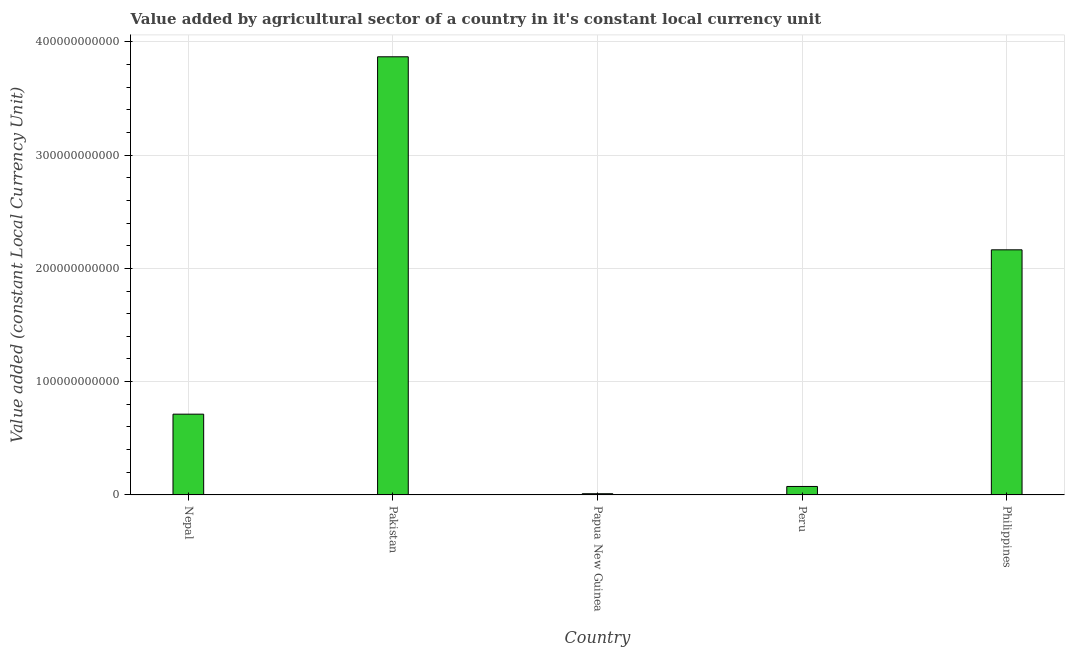Does the graph contain any zero values?
Give a very brief answer. No. What is the title of the graph?
Your response must be concise. Value added by agricultural sector of a country in it's constant local currency unit. What is the label or title of the Y-axis?
Offer a very short reply. Value added (constant Local Currency Unit). What is the value added by agriculture sector in Pakistan?
Provide a succinct answer. 3.87e+11. Across all countries, what is the maximum value added by agriculture sector?
Your answer should be compact. 3.87e+11. Across all countries, what is the minimum value added by agriculture sector?
Your answer should be compact. 1.06e+09. In which country was the value added by agriculture sector minimum?
Provide a succinct answer. Papua New Guinea. What is the sum of the value added by agriculture sector?
Give a very brief answer. 6.83e+11. What is the difference between the value added by agriculture sector in Nepal and Pakistan?
Your answer should be compact. -3.15e+11. What is the average value added by agriculture sector per country?
Offer a very short reply. 1.37e+11. What is the median value added by agriculture sector?
Ensure brevity in your answer.  7.13e+1. What is the ratio of the value added by agriculture sector in Nepal to that in Pakistan?
Your response must be concise. 0.18. Is the value added by agriculture sector in Peru less than that in Philippines?
Make the answer very short. Yes. Is the difference between the value added by agriculture sector in Peru and Philippines greater than the difference between any two countries?
Provide a succinct answer. No. What is the difference between the highest and the second highest value added by agriculture sector?
Make the answer very short. 1.70e+11. Is the sum of the value added by agriculture sector in Nepal and Pakistan greater than the maximum value added by agriculture sector across all countries?
Your answer should be very brief. Yes. What is the difference between the highest and the lowest value added by agriculture sector?
Your response must be concise. 3.86e+11. How many bars are there?
Give a very brief answer. 5. Are all the bars in the graph horizontal?
Provide a short and direct response. No. How many countries are there in the graph?
Provide a succinct answer. 5. What is the difference between two consecutive major ticks on the Y-axis?
Your answer should be very brief. 1.00e+11. What is the Value added (constant Local Currency Unit) of Nepal?
Give a very brief answer. 7.13e+1. What is the Value added (constant Local Currency Unit) in Pakistan?
Your answer should be very brief. 3.87e+11. What is the Value added (constant Local Currency Unit) in Papua New Guinea?
Keep it short and to the point. 1.06e+09. What is the Value added (constant Local Currency Unit) of Peru?
Your answer should be very brief. 7.48e+09. What is the Value added (constant Local Currency Unit) of Philippines?
Your answer should be very brief. 2.16e+11. What is the difference between the Value added (constant Local Currency Unit) in Nepal and Pakistan?
Your response must be concise. -3.15e+11. What is the difference between the Value added (constant Local Currency Unit) in Nepal and Papua New Guinea?
Your answer should be compact. 7.02e+1. What is the difference between the Value added (constant Local Currency Unit) in Nepal and Peru?
Give a very brief answer. 6.38e+1. What is the difference between the Value added (constant Local Currency Unit) in Nepal and Philippines?
Make the answer very short. -1.45e+11. What is the difference between the Value added (constant Local Currency Unit) in Pakistan and Papua New Guinea?
Ensure brevity in your answer.  3.86e+11. What is the difference between the Value added (constant Local Currency Unit) in Pakistan and Peru?
Make the answer very short. 3.79e+11. What is the difference between the Value added (constant Local Currency Unit) in Pakistan and Philippines?
Your answer should be compact. 1.70e+11. What is the difference between the Value added (constant Local Currency Unit) in Papua New Guinea and Peru?
Give a very brief answer. -6.41e+09. What is the difference between the Value added (constant Local Currency Unit) in Papua New Guinea and Philippines?
Offer a very short reply. -2.15e+11. What is the difference between the Value added (constant Local Currency Unit) in Peru and Philippines?
Offer a terse response. -2.09e+11. What is the ratio of the Value added (constant Local Currency Unit) in Nepal to that in Pakistan?
Offer a very short reply. 0.18. What is the ratio of the Value added (constant Local Currency Unit) in Nepal to that in Papua New Guinea?
Offer a very short reply. 67.02. What is the ratio of the Value added (constant Local Currency Unit) in Nepal to that in Peru?
Keep it short and to the point. 9.54. What is the ratio of the Value added (constant Local Currency Unit) in Nepal to that in Philippines?
Make the answer very short. 0.33. What is the ratio of the Value added (constant Local Currency Unit) in Pakistan to that in Papua New Guinea?
Your response must be concise. 363.52. What is the ratio of the Value added (constant Local Currency Unit) in Pakistan to that in Peru?
Keep it short and to the point. 51.73. What is the ratio of the Value added (constant Local Currency Unit) in Pakistan to that in Philippines?
Keep it short and to the point. 1.79. What is the ratio of the Value added (constant Local Currency Unit) in Papua New Guinea to that in Peru?
Your answer should be compact. 0.14. What is the ratio of the Value added (constant Local Currency Unit) in Papua New Guinea to that in Philippines?
Provide a short and direct response. 0.01. What is the ratio of the Value added (constant Local Currency Unit) in Peru to that in Philippines?
Offer a terse response. 0.04. 